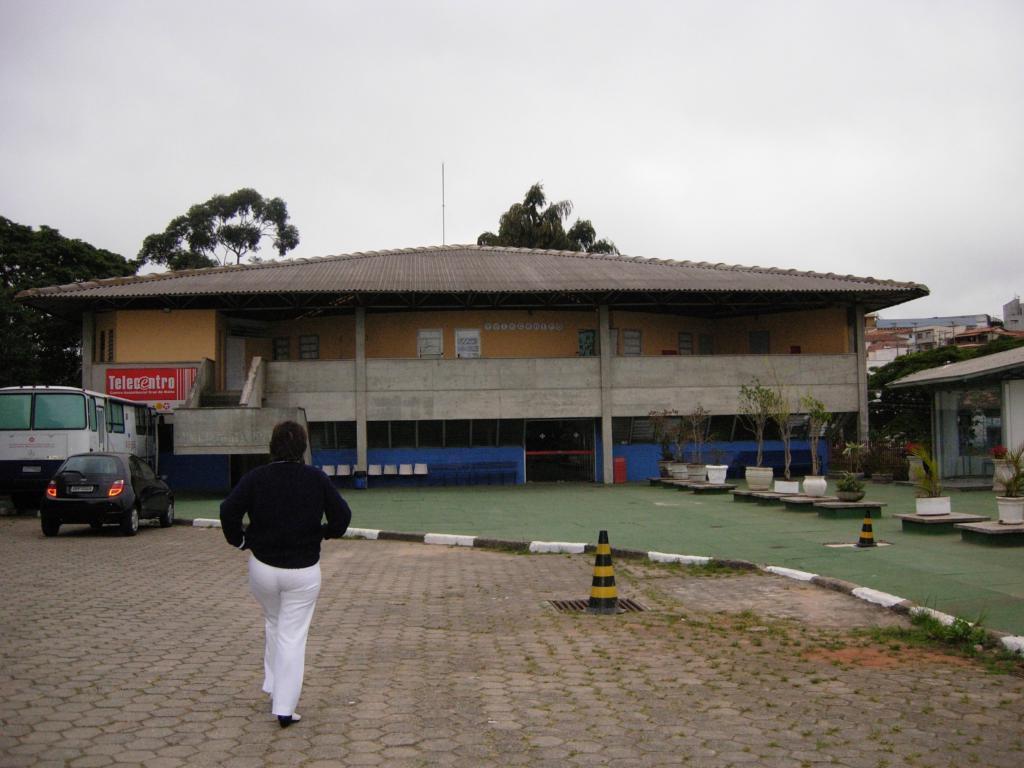How would you summarize this image in a sentence or two? In this image I can see few sheds. In-front of the shed there are vehicles. And I can see the person walking on the road and wearing the black and white dress. To the side I can see the traffic cones and also the plants. In the back there are trees and the white sky. 